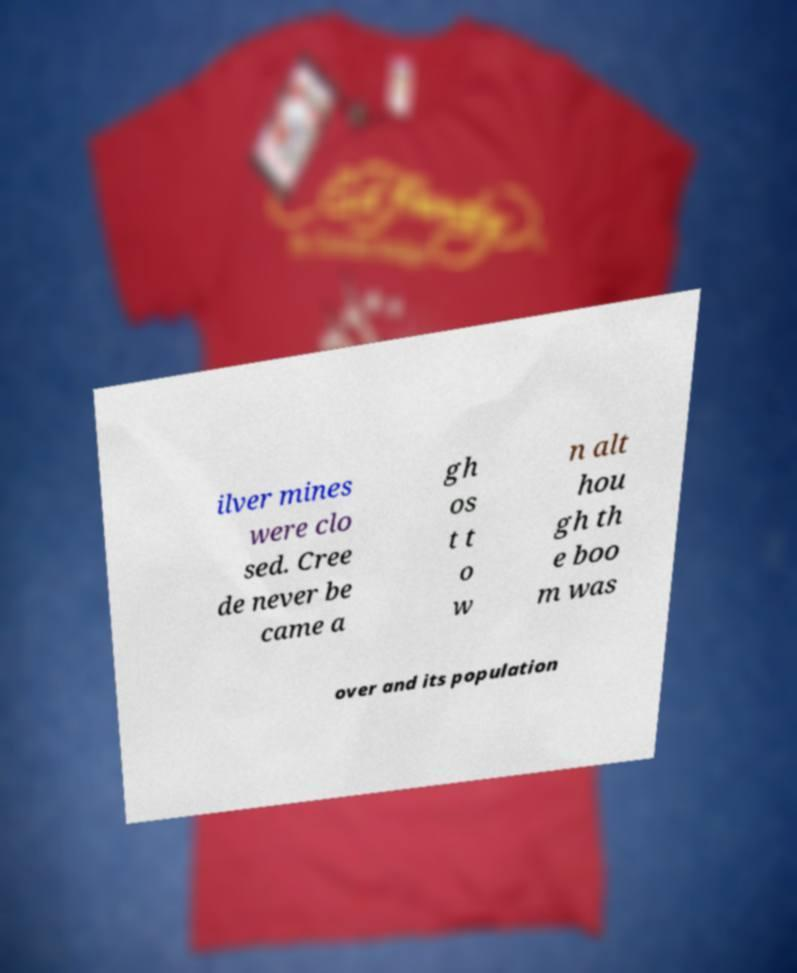Please read and relay the text visible in this image. What does it say? ilver mines were clo sed. Cree de never be came a gh os t t o w n alt hou gh th e boo m was over and its population 